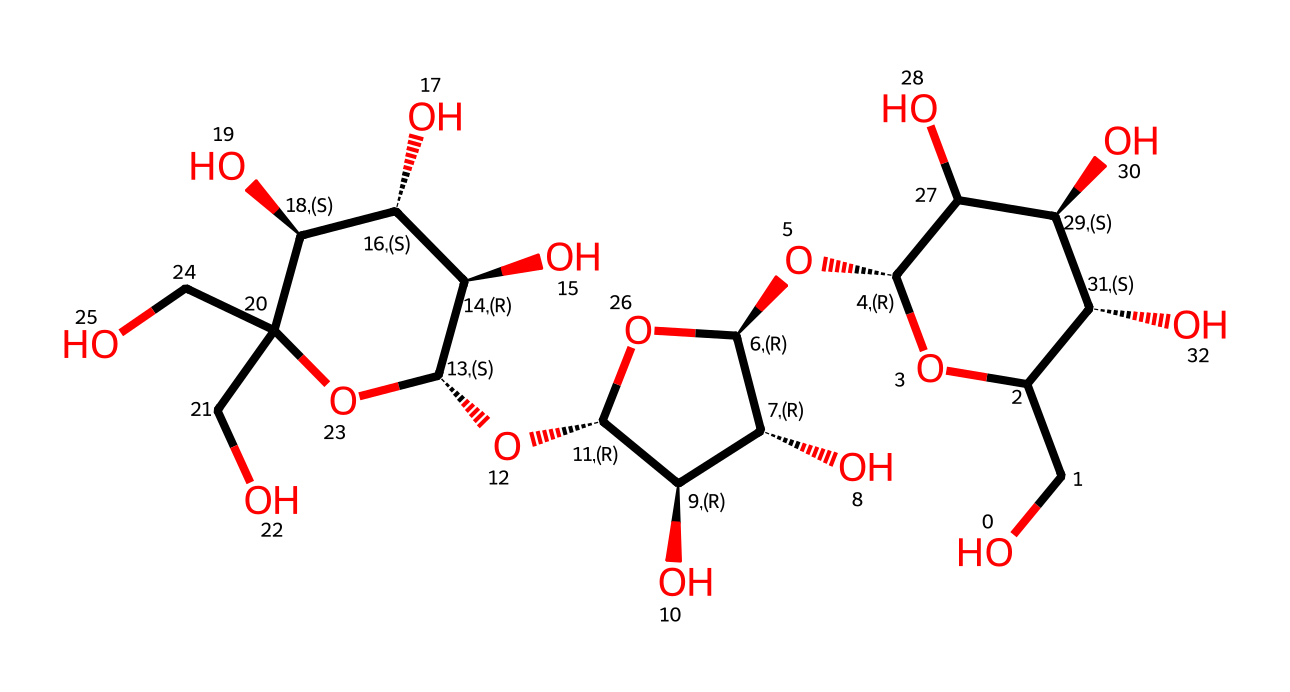how many carbon atoms are in this structure? To determine the number of carbon atoms, I count the carbon (C) symbols in the chemical structure represented by the SMILES notation. In this case, I can identify 6 distinct carbon atoms in addition to those linked in the cyclic structures.
Answer: six how many hydroxyl (OH) groups are present in this molecule? I analyze the chemical structure for the OH groups by looking for the symbol that represents hydroxyl groups within the SMILES notation. There are multiple instances where OH occurs, totaling 5 OH groups.
Answer: five what type of carbohydrate is represented by this structure? This structure can be identified as cellulose, a polysaccharide, due to its long linear chains of glucose units and the presence of multiple hydroxyl groups, characteristic of cellulose.
Answer: cellulose which part of the structure contributes to its water solubility? The numerous hydroxyl groups (OH) in the chemical structure are responsible for the high water solubility because they can form hydrogen bonds with water molecules.
Answer: hydroxyl groups what is the role of cellulose in paper used for poetry manuscripts? Cellulose serves as the primary structural component in paper, providing strength and durability while remaining a biodegradable and renewable resource.
Answer: structural component how does the chemical structure of cellulose affect its digestibility? The beta-glycosidic linkages in the cellulose structure create a tightly packed polymer that is resistant to enzymatic breakdown in the human digestive system, making it largely indigestible.
Answer: resistant to digestion 